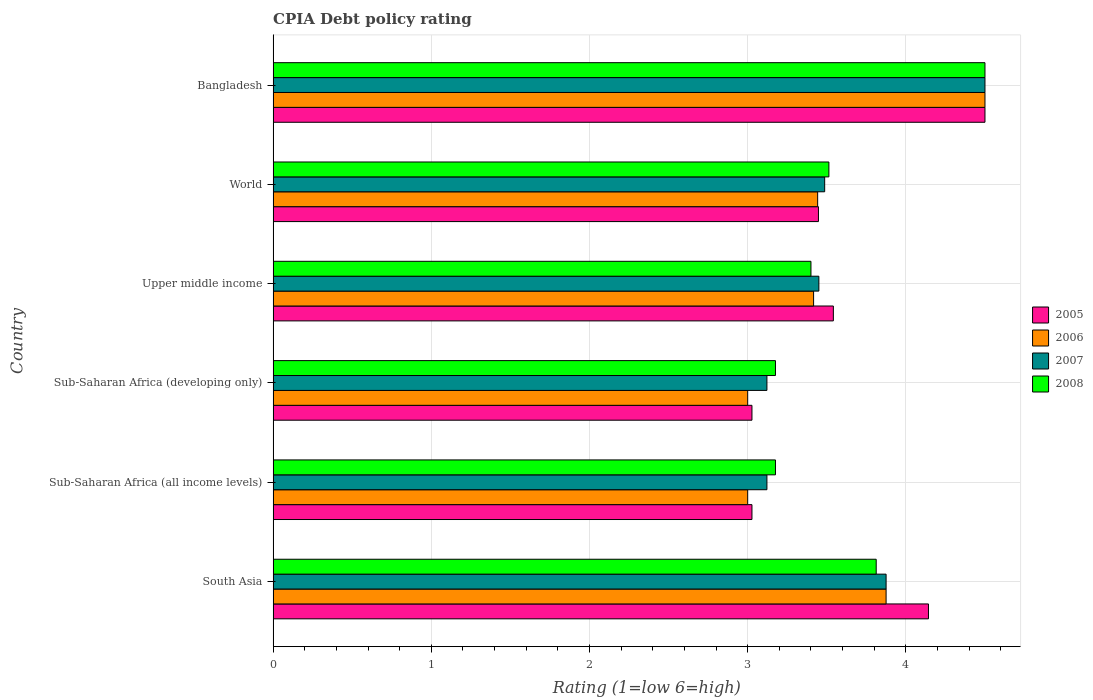How many different coloured bars are there?
Ensure brevity in your answer.  4. How many groups of bars are there?
Your answer should be very brief. 6. Are the number of bars on each tick of the Y-axis equal?
Provide a short and direct response. Yes. How many bars are there on the 6th tick from the top?
Offer a very short reply. 4. How many bars are there on the 5th tick from the bottom?
Offer a terse response. 4. What is the label of the 3rd group of bars from the top?
Make the answer very short. Upper middle income. In how many cases, is the number of bars for a given country not equal to the number of legend labels?
Provide a short and direct response. 0. What is the CPIA rating in 2007 in South Asia?
Give a very brief answer. 3.88. Across all countries, what is the minimum CPIA rating in 2006?
Provide a succinct answer. 3. In which country was the CPIA rating in 2007 minimum?
Your response must be concise. Sub-Saharan Africa (all income levels). What is the total CPIA rating in 2007 in the graph?
Provide a succinct answer. 21.55. What is the difference between the CPIA rating in 2007 in Bangladesh and that in Upper middle income?
Ensure brevity in your answer.  1.05. What is the difference between the CPIA rating in 2005 in South Asia and the CPIA rating in 2007 in Sub-Saharan Africa (developing only)?
Your answer should be very brief. 1.02. What is the average CPIA rating in 2008 per country?
Give a very brief answer. 3.6. What is the difference between the CPIA rating in 2005 and CPIA rating in 2008 in South Asia?
Provide a succinct answer. 0.33. In how many countries, is the CPIA rating in 2005 greater than 3.6 ?
Make the answer very short. 2. What is the ratio of the CPIA rating in 2008 in Sub-Saharan Africa (developing only) to that in World?
Make the answer very short. 0.9. What is the difference between the highest and the second highest CPIA rating in 2008?
Ensure brevity in your answer.  0.69. What is the difference between the highest and the lowest CPIA rating in 2006?
Offer a terse response. 1.5. Is it the case that in every country, the sum of the CPIA rating in 2007 and CPIA rating in 2005 is greater than the sum of CPIA rating in 2008 and CPIA rating in 2006?
Provide a short and direct response. No. What does the 1st bar from the top in South Asia represents?
Your answer should be very brief. 2008. Are all the bars in the graph horizontal?
Keep it short and to the point. Yes. What is the difference between two consecutive major ticks on the X-axis?
Your answer should be compact. 1. Are the values on the major ticks of X-axis written in scientific E-notation?
Keep it short and to the point. No. Does the graph contain any zero values?
Offer a terse response. No. How are the legend labels stacked?
Your response must be concise. Vertical. What is the title of the graph?
Provide a succinct answer. CPIA Debt policy rating. What is the label or title of the Y-axis?
Your response must be concise. Country. What is the Rating (1=low 6=high) in 2005 in South Asia?
Make the answer very short. 4.14. What is the Rating (1=low 6=high) of 2006 in South Asia?
Ensure brevity in your answer.  3.88. What is the Rating (1=low 6=high) in 2007 in South Asia?
Offer a very short reply. 3.88. What is the Rating (1=low 6=high) of 2008 in South Asia?
Ensure brevity in your answer.  3.81. What is the Rating (1=low 6=high) in 2005 in Sub-Saharan Africa (all income levels)?
Ensure brevity in your answer.  3.03. What is the Rating (1=low 6=high) in 2007 in Sub-Saharan Africa (all income levels)?
Provide a short and direct response. 3.12. What is the Rating (1=low 6=high) in 2008 in Sub-Saharan Africa (all income levels)?
Keep it short and to the point. 3.18. What is the Rating (1=low 6=high) in 2005 in Sub-Saharan Africa (developing only)?
Your answer should be very brief. 3.03. What is the Rating (1=low 6=high) of 2007 in Sub-Saharan Africa (developing only)?
Offer a terse response. 3.12. What is the Rating (1=low 6=high) of 2008 in Sub-Saharan Africa (developing only)?
Ensure brevity in your answer.  3.18. What is the Rating (1=low 6=high) in 2005 in Upper middle income?
Your answer should be compact. 3.54. What is the Rating (1=low 6=high) in 2006 in Upper middle income?
Give a very brief answer. 3.42. What is the Rating (1=low 6=high) in 2007 in Upper middle income?
Your answer should be compact. 3.45. What is the Rating (1=low 6=high) in 2008 in Upper middle income?
Your response must be concise. 3.4. What is the Rating (1=low 6=high) of 2005 in World?
Give a very brief answer. 3.45. What is the Rating (1=low 6=high) in 2006 in World?
Your answer should be very brief. 3.44. What is the Rating (1=low 6=high) in 2007 in World?
Offer a terse response. 3.49. What is the Rating (1=low 6=high) in 2008 in World?
Make the answer very short. 3.51. What is the Rating (1=low 6=high) of 2005 in Bangladesh?
Your answer should be very brief. 4.5. What is the Rating (1=low 6=high) in 2007 in Bangladesh?
Your response must be concise. 4.5. What is the Rating (1=low 6=high) of 2008 in Bangladesh?
Offer a terse response. 4.5. Across all countries, what is the maximum Rating (1=low 6=high) in 2006?
Provide a short and direct response. 4.5. Across all countries, what is the maximum Rating (1=low 6=high) in 2007?
Offer a terse response. 4.5. Across all countries, what is the maximum Rating (1=low 6=high) in 2008?
Offer a very short reply. 4.5. Across all countries, what is the minimum Rating (1=low 6=high) in 2005?
Provide a succinct answer. 3.03. Across all countries, what is the minimum Rating (1=low 6=high) of 2007?
Offer a very short reply. 3.12. Across all countries, what is the minimum Rating (1=low 6=high) of 2008?
Your response must be concise. 3.18. What is the total Rating (1=low 6=high) in 2005 in the graph?
Your answer should be compact. 21.69. What is the total Rating (1=low 6=high) in 2006 in the graph?
Ensure brevity in your answer.  21.23. What is the total Rating (1=low 6=high) in 2007 in the graph?
Make the answer very short. 21.55. What is the total Rating (1=low 6=high) of 2008 in the graph?
Give a very brief answer. 21.58. What is the difference between the Rating (1=low 6=high) of 2005 in South Asia and that in Sub-Saharan Africa (all income levels)?
Offer a very short reply. 1.12. What is the difference between the Rating (1=low 6=high) of 2007 in South Asia and that in Sub-Saharan Africa (all income levels)?
Make the answer very short. 0.75. What is the difference between the Rating (1=low 6=high) in 2008 in South Asia and that in Sub-Saharan Africa (all income levels)?
Provide a short and direct response. 0.64. What is the difference between the Rating (1=low 6=high) in 2005 in South Asia and that in Sub-Saharan Africa (developing only)?
Ensure brevity in your answer.  1.12. What is the difference between the Rating (1=low 6=high) in 2007 in South Asia and that in Sub-Saharan Africa (developing only)?
Your response must be concise. 0.75. What is the difference between the Rating (1=low 6=high) of 2008 in South Asia and that in Sub-Saharan Africa (developing only)?
Keep it short and to the point. 0.64. What is the difference between the Rating (1=low 6=high) in 2005 in South Asia and that in Upper middle income?
Your answer should be compact. 0.6. What is the difference between the Rating (1=low 6=high) in 2006 in South Asia and that in Upper middle income?
Provide a short and direct response. 0.46. What is the difference between the Rating (1=low 6=high) of 2007 in South Asia and that in Upper middle income?
Ensure brevity in your answer.  0.42. What is the difference between the Rating (1=low 6=high) of 2008 in South Asia and that in Upper middle income?
Give a very brief answer. 0.41. What is the difference between the Rating (1=low 6=high) of 2005 in South Asia and that in World?
Ensure brevity in your answer.  0.7. What is the difference between the Rating (1=low 6=high) of 2006 in South Asia and that in World?
Your answer should be compact. 0.43. What is the difference between the Rating (1=low 6=high) in 2007 in South Asia and that in World?
Give a very brief answer. 0.39. What is the difference between the Rating (1=low 6=high) of 2008 in South Asia and that in World?
Your answer should be compact. 0.3. What is the difference between the Rating (1=low 6=high) in 2005 in South Asia and that in Bangladesh?
Your answer should be very brief. -0.36. What is the difference between the Rating (1=low 6=high) in 2006 in South Asia and that in Bangladesh?
Your answer should be very brief. -0.62. What is the difference between the Rating (1=low 6=high) in 2007 in South Asia and that in Bangladesh?
Give a very brief answer. -0.62. What is the difference between the Rating (1=low 6=high) of 2008 in South Asia and that in Bangladesh?
Your answer should be very brief. -0.69. What is the difference between the Rating (1=low 6=high) in 2005 in Sub-Saharan Africa (all income levels) and that in Sub-Saharan Africa (developing only)?
Offer a very short reply. 0. What is the difference between the Rating (1=low 6=high) of 2008 in Sub-Saharan Africa (all income levels) and that in Sub-Saharan Africa (developing only)?
Provide a succinct answer. 0. What is the difference between the Rating (1=low 6=high) in 2005 in Sub-Saharan Africa (all income levels) and that in Upper middle income?
Give a very brief answer. -0.51. What is the difference between the Rating (1=low 6=high) of 2006 in Sub-Saharan Africa (all income levels) and that in Upper middle income?
Your response must be concise. -0.42. What is the difference between the Rating (1=low 6=high) in 2007 in Sub-Saharan Africa (all income levels) and that in Upper middle income?
Your response must be concise. -0.33. What is the difference between the Rating (1=low 6=high) in 2008 in Sub-Saharan Africa (all income levels) and that in Upper middle income?
Offer a terse response. -0.22. What is the difference between the Rating (1=low 6=high) in 2005 in Sub-Saharan Africa (all income levels) and that in World?
Your answer should be compact. -0.42. What is the difference between the Rating (1=low 6=high) of 2006 in Sub-Saharan Africa (all income levels) and that in World?
Keep it short and to the point. -0.44. What is the difference between the Rating (1=low 6=high) of 2007 in Sub-Saharan Africa (all income levels) and that in World?
Ensure brevity in your answer.  -0.36. What is the difference between the Rating (1=low 6=high) in 2008 in Sub-Saharan Africa (all income levels) and that in World?
Give a very brief answer. -0.34. What is the difference between the Rating (1=low 6=high) in 2005 in Sub-Saharan Africa (all income levels) and that in Bangladesh?
Your answer should be compact. -1.47. What is the difference between the Rating (1=low 6=high) of 2007 in Sub-Saharan Africa (all income levels) and that in Bangladesh?
Your response must be concise. -1.38. What is the difference between the Rating (1=low 6=high) of 2008 in Sub-Saharan Africa (all income levels) and that in Bangladesh?
Make the answer very short. -1.32. What is the difference between the Rating (1=low 6=high) of 2005 in Sub-Saharan Africa (developing only) and that in Upper middle income?
Ensure brevity in your answer.  -0.51. What is the difference between the Rating (1=low 6=high) in 2006 in Sub-Saharan Africa (developing only) and that in Upper middle income?
Keep it short and to the point. -0.42. What is the difference between the Rating (1=low 6=high) in 2007 in Sub-Saharan Africa (developing only) and that in Upper middle income?
Provide a succinct answer. -0.33. What is the difference between the Rating (1=low 6=high) in 2008 in Sub-Saharan Africa (developing only) and that in Upper middle income?
Ensure brevity in your answer.  -0.22. What is the difference between the Rating (1=low 6=high) in 2005 in Sub-Saharan Africa (developing only) and that in World?
Offer a terse response. -0.42. What is the difference between the Rating (1=low 6=high) of 2006 in Sub-Saharan Africa (developing only) and that in World?
Keep it short and to the point. -0.44. What is the difference between the Rating (1=low 6=high) of 2007 in Sub-Saharan Africa (developing only) and that in World?
Offer a terse response. -0.36. What is the difference between the Rating (1=low 6=high) in 2008 in Sub-Saharan Africa (developing only) and that in World?
Ensure brevity in your answer.  -0.34. What is the difference between the Rating (1=low 6=high) of 2005 in Sub-Saharan Africa (developing only) and that in Bangladesh?
Make the answer very short. -1.47. What is the difference between the Rating (1=low 6=high) in 2007 in Sub-Saharan Africa (developing only) and that in Bangladesh?
Give a very brief answer. -1.38. What is the difference between the Rating (1=low 6=high) in 2008 in Sub-Saharan Africa (developing only) and that in Bangladesh?
Provide a succinct answer. -1.32. What is the difference between the Rating (1=low 6=high) in 2005 in Upper middle income and that in World?
Make the answer very short. 0.09. What is the difference between the Rating (1=low 6=high) in 2006 in Upper middle income and that in World?
Give a very brief answer. -0.03. What is the difference between the Rating (1=low 6=high) in 2007 in Upper middle income and that in World?
Make the answer very short. -0.04. What is the difference between the Rating (1=low 6=high) of 2008 in Upper middle income and that in World?
Give a very brief answer. -0.11. What is the difference between the Rating (1=low 6=high) of 2005 in Upper middle income and that in Bangladesh?
Give a very brief answer. -0.96. What is the difference between the Rating (1=low 6=high) in 2006 in Upper middle income and that in Bangladesh?
Provide a short and direct response. -1.08. What is the difference between the Rating (1=low 6=high) in 2007 in Upper middle income and that in Bangladesh?
Keep it short and to the point. -1.05. What is the difference between the Rating (1=low 6=high) of 2005 in World and that in Bangladesh?
Offer a terse response. -1.05. What is the difference between the Rating (1=low 6=high) of 2006 in World and that in Bangladesh?
Make the answer very short. -1.06. What is the difference between the Rating (1=low 6=high) of 2007 in World and that in Bangladesh?
Make the answer very short. -1.01. What is the difference between the Rating (1=low 6=high) of 2008 in World and that in Bangladesh?
Your response must be concise. -0.99. What is the difference between the Rating (1=low 6=high) in 2005 in South Asia and the Rating (1=low 6=high) in 2006 in Sub-Saharan Africa (all income levels)?
Make the answer very short. 1.14. What is the difference between the Rating (1=low 6=high) in 2005 in South Asia and the Rating (1=low 6=high) in 2007 in Sub-Saharan Africa (all income levels)?
Provide a succinct answer. 1.02. What is the difference between the Rating (1=low 6=high) of 2005 in South Asia and the Rating (1=low 6=high) of 2008 in Sub-Saharan Africa (all income levels)?
Offer a very short reply. 0.97. What is the difference between the Rating (1=low 6=high) of 2006 in South Asia and the Rating (1=low 6=high) of 2007 in Sub-Saharan Africa (all income levels)?
Provide a short and direct response. 0.75. What is the difference between the Rating (1=low 6=high) in 2006 in South Asia and the Rating (1=low 6=high) in 2008 in Sub-Saharan Africa (all income levels)?
Provide a succinct answer. 0.7. What is the difference between the Rating (1=low 6=high) of 2007 in South Asia and the Rating (1=low 6=high) of 2008 in Sub-Saharan Africa (all income levels)?
Make the answer very short. 0.7. What is the difference between the Rating (1=low 6=high) in 2005 in South Asia and the Rating (1=low 6=high) in 2007 in Sub-Saharan Africa (developing only)?
Ensure brevity in your answer.  1.02. What is the difference between the Rating (1=low 6=high) in 2005 in South Asia and the Rating (1=low 6=high) in 2008 in Sub-Saharan Africa (developing only)?
Make the answer very short. 0.97. What is the difference between the Rating (1=low 6=high) in 2006 in South Asia and the Rating (1=low 6=high) in 2007 in Sub-Saharan Africa (developing only)?
Provide a succinct answer. 0.75. What is the difference between the Rating (1=low 6=high) in 2006 in South Asia and the Rating (1=low 6=high) in 2008 in Sub-Saharan Africa (developing only)?
Provide a short and direct response. 0.7. What is the difference between the Rating (1=low 6=high) in 2007 in South Asia and the Rating (1=low 6=high) in 2008 in Sub-Saharan Africa (developing only)?
Keep it short and to the point. 0.7. What is the difference between the Rating (1=low 6=high) in 2005 in South Asia and the Rating (1=low 6=high) in 2006 in Upper middle income?
Your answer should be very brief. 0.73. What is the difference between the Rating (1=low 6=high) in 2005 in South Asia and the Rating (1=low 6=high) in 2007 in Upper middle income?
Offer a very short reply. 0.69. What is the difference between the Rating (1=low 6=high) in 2005 in South Asia and the Rating (1=low 6=high) in 2008 in Upper middle income?
Make the answer very short. 0.74. What is the difference between the Rating (1=low 6=high) of 2006 in South Asia and the Rating (1=low 6=high) of 2007 in Upper middle income?
Your answer should be compact. 0.42. What is the difference between the Rating (1=low 6=high) in 2006 in South Asia and the Rating (1=low 6=high) in 2008 in Upper middle income?
Keep it short and to the point. 0.47. What is the difference between the Rating (1=low 6=high) of 2007 in South Asia and the Rating (1=low 6=high) of 2008 in Upper middle income?
Give a very brief answer. 0.47. What is the difference between the Rating (1=low 6=high) in 2005 in South Asia and the Rating (1=low 6=high) in 2006 in World?
Keep it short and to the point. 0.7. What is the difference between the Rating (1=low 6=high) in 2005 in South Asia and the Rating (1=low 6=high) in 2007 in World?
Make the answer very short. 0.66. What is the difference between the Rating (1=low 6=high) of 2005 in South Asia and the Rating (1=low 6=high) of 2008 in World?
Make the answer very short. 0.63. What is the difference between the Rating (1=low 6=high) in 2006 in South Asia and the Rating (1=low 6=high) in 2007 in World?
Your response must be concise. 0.39. What is the difference between the Rating (1=low 6=high) of 2006 in South Asia and the Rating (1=low 6=high) of 2008 in World?
Offer a terse response. 0.36. What is the difference between the Rating (1=low 6=high) in 2007 in South Asia and the Rating (1=low 6=high) in 2008 in World?
Your answer should be very brief. 0.36. What is the difference between the Rating (1=low 6=high) in 2005 in South Asia and the Rating (1=low 6=high) in 2006 in Bangladesh?
Your answer should be very brief. -0.36. What is the difference between the Rating (1=low 6=high) of 2005 in South Asia and the Rating (1=low 6=high) of 2007 in Bangladesh?
Offer a terse response. -0.36. What is the difference between the Rating (1=low 6=high) of 2005 in South Asia and the Rating (1=low 6=high) of 2008 in Bangladesh?
Ensure brevity in your answer.  -0.36. What is the difference between the Rating (1=low 6=high) of 2006 in South Asia and the Rating (1=low 6=high) of 2007 in Bangladesh?
Offer a terse response. -0.62. What is the difference between the Rating (1=low 6=high) of 2006 in South Asia and the Rating (1=low 6=high) of 2008 in Bangladesh?
Your answer should be compact. -0.62. What is the difference between the Rating (1=low 6=high) of 2007 in South Asia and the Rating (1=low 6=high) of 2008 in Bangladesh?
Your response must be concise. -0.62. What is the difference between the Rating (1=low 6=high) of 2005 in Sub-Saharan Africa (all income levels) and the Rating (1=low 6=high) of 2006 in Sub-Saharan Africa (developing only)?
Your answer should be compact. 0.03. What is the difference between the Rating (1=low 6=high) of 2005 in Sub-Saharan Africa (all income levels) and the Rating (1=low 6=high) of 2007 in Sub-Saharan Africa (developing only)?
Your answer should be very brief. -0.09. What is the difference between the Rating (1=low 6=high) in 2005 in Sub-Saharan Africa (all income levels) and the Rating (1=low 6=high) in 2008 in Sub-Saharan Africa (developing only)?
Give a very brief answer. -0.15. What is the difference between the Rating (1=low 6=high) of 2006 in Sub-Saharan Africa (all income levels) and the Rating (1=low 6=high) of 2007 in Sub-Saharan Africa (developing only)?
Ensure brevity in your answer.  -0.12. What is the difference between the Rating (1=low 6=high) of 2006 in Sub-Saharan Africa (all income levels) and the Rating (1=low 6=high) of 2008 in Sub-Saharan Africa (developing only)?
Your response must be concise. -0.18. What is the difference between the Rating (1=low 6=high) in 2007 in Sub-Saharan Africa (all income levels) and the Rating (1=low 6=high) in 2008 in Sub-Saharan Africa (developing only)?
Your answer should be very brief. -0.05. What is the difference between the Rating (1=low 6=high) in 2005 in Sub-Saharan Africa (all income levels) and the Rating (1=low 6=high) in 2006 in Upper middle income?
Ensure brevity in your answer.  -0.39. What is the difference between the Rating (1=low 6=high) in 2005 in Sub-Saharan Africa (all income levels) and the Rating (1=low 6=high) in 2007 in Upper middle income?
Provide a succinct answer. -0.42. What is the difference between the Rating (1=low 6=high) of 2005 in Sub-Saharan Africa (all income levels) and the Rating (1=low 6=high) of 2008 in Upper middle income?
Offer a terse response. -0.37. What is the difference between the Rating (1=low 6=high) of 2006 in Sub-Saharan Africa (all income levels) and the Rating (1=low 6=high) of 2007 in Upper middle income?
Offer a terse response. -0.45. What is the difference between the Rating (1=low 6=high) in 2007 in Sub-Saharan Africa (all income levels) and the Rating (1=low 6=high) in 2008 in Upper middle income?
Make the answer very short. -0.28. What is the difference between the Rating (1=low 6=high) in 2005 in Sub-Saharan Africa (all income levels) and the Rating (1=low 6=high) in 2006 in World?
Offer a very short reply. -0.42. What is the difference between the Rating (1=low 6=high) in 2005 in Sub-Saharan Africa (all income levels) and the Rating (1=low 6=high) in 2007 in World?
Your answer should be very brief. -0.46. What is the difference between the Rating (1=low 6=high) of 2005 in Sub-Saharan Africa (all income levels) and the Rating (1=low 6=high) of 2008 in World?
Provide a short and direct response. -0.49. What is the difference between the Rating (1=low 6=high) in 2006 in Sub-Saharan Africa (all income levels) and the Rating (1=low 6=high) in 2007 in World?
Your answer should be very brief. -0.49. What is the difference between the Rating (1=low 6=high) of 2006 in Sub-Saharan Africa (all income levels) and the Rating (1=low 6=high) of 2008 in World?
Make the answer very short. -0.51. What is the difference between the Rating (1=low 6=high) of 2007 in Sub-Saharan Africa (all income levels) and the Rating (1=low 6=high) of 2008 in World?
Ensure brevity in your answer.  -0.39. What is the difference between the Rating (1=low 6=high) in 2005 in Sub-Saharan Africa (all income levels) and the Rating (1=low 6=high) in 2006 in Bangladesh?
Provide a short and direct response. -1.47. What is the difference between the Rating (1=low 6=high) in 2005 in Sub-Saharan Africa (all income levels) and the Rating (1=low 6=high) in 2007 in Bangladesh?
Provide a short and direct response. -1.47. What is the difference between the Rating (1=low 6=high) of 2005 in Sub-Saharan Africa (all income levels) and the Rating (1=low 6=high) of 2008 in Bangladesh?
Make the answer very short. -1.47. What is the difference between the Rating (1=low 6=high) of 2006 in Sub-Saharan Africa (all income levels) and the Rating (1=low 6=high) of 2008 in Bangladesh?
Provide a short and direct response. -1.5. What is the difference between the Rating (1=low 6=high) of 2007 in Sub-Saharan Africa (all income levels) and the Rating (1=low 6=high) of 2008 in Bangladesh?
Provide a succinct answer. -1.38. What is the difference between the Rating (1=low 6=high) in 2005 in Sub-Saharan Africa (developing only) and the Rating (1=low 6=high) in 2006 in Upper middle income?
Make the answer very short. -0.39. What is the difference between the Rating (1=low 6=high) in 2005 in Sub-Saharan Africa (developing only) and the Rating (1=low 6=high) in 2007 in Upper middle income?
Ensure brevity in your answer.  -0.42. What is the difference between the Rating (1=low 6=high) of 2005 in Sub-Saharan Africa (developing only) and the Rating (1=low 6=high) of 2008 in Upper middle income?
Provide a short and direct response. -0.37. What is the difference between the Rating (1=low 6=high) in 2006 in Sub-Saharan Africa (developing only) and the Rating (1=low 6=high) in 2007 in Upper middle income?
Ensure brevity in your answer.  -0.45. What is the difference between the Rating (1=low 6=high) of 2006 in Sub-Saharan Africa (developing only) and the Rating (1=low 6=high) of 2008 in Upper middle income?
Your response must be concise. -0.4. What is the difference between the Rating (1=low 6=high) of 2007 in Sub-Saharan Africa (developing only) and the Rating (1=low 6=high) of 2008 in Upper middle income?
Make the answer very short. -0.28. What is the difference between the Rating (1=low 6=high) of 2005 in Sub-Saharan Africa (developing only) and the Rating (1=low 6=high) of 2006 in World?
Keep it short and to the point. -0.42. What is the difference between the Rating (1=low 6=high) of 2005 in Sub-Saharan Africa (developing only) and the Rating (1=low 6=high) of 2007 in World?
Ensure brevity in your answer.  -0.46. What is the difference between the Rating (1=low 6=high) of 2005 in Sub-Saharan Africa (developing only) and the Rating (1=low 6=high) of 2008 in World?
Your answer should be very brief. -0.49. What is the difference between the Rating (1=low 6=high) in 2006 in Sub-Saharan Africa (developing only) and the Rating (1=low 6=high) in 2007 in World?
Provide a succinct answer. -0.49. What is the difference between the Rating (1=low 6=high) of 2006 in Sub-Saharan Africa (developing only) and the Rating (1=low 6=high) of 2008 in World?
Keep it short and to the point. -0.51. What is the difference between the Rating (1=low 6=high) in 2007 in Sub-Saharan Africa (developing only) and the Rating (1=low 6=high) in 2008 in World?
Your response must be concise. -0.39. What is the difference between the Rating (1=low 6=high) of 2005 in Sub-Saharan Africa (developing only) and the Rating (1=low 6=high) of 2006 in Bangladesh?
Your answer should be compact. -1.47. What is the difference between the Rating (1=low 6=high) in 2005 in Sub-Saharan Africa (developing only) and the Rating (1=low 6=high) in 2007 in Bangladesh?
Give a very brief answer. -1.47. What is the difference between the Rating (1=low 6=high) of 2005 in Sub-Saharan Africa (developing only) and the Rating (1=low 6=high) of 2008 in Bangladesh?
Your answer should be very brief. -1.47. What is the difference between the Rating (1=low 6=high) in 2006 in Sub-Saharan Africa (developing only) and the Rating (1=low 6=high) in 2007 in Bangladesh?
Your answer should be very brief. -1.5. What is the difference between the Rating (1=low 6=high) of 2006 in Sub-Saharan Africa (developing only) and the Rating (1=low 6=high) of 2008 in Bangladesh?
Keep it short and to the point. -1.5. What is the difference between the Rating (1=low 6=high) in 2007 in Sub-Saharan Africa (developing only) and the Rating (1=low 6=high) in 2008 in Bangladesh?
Provide a succinct answer. -1.38. What is the difference between the Rating (1=low 6=high) in 2005 in Upper middle income and the Rating (1=low 6=high) in 2006 in World?
Your answer should be very brief. 0.1. What is the difference between the Rating (1=low 6=high) of 2005 in Upper middle income and the Rating (1=low 6=high) of 2007 in World?
Your answer should be very brief. 0.06. What is the difference between the Rating (1=low 6=high) of 2005 in Upper middle income and the Rating (1=low 6=high) of 2008 in World?
Your response must be concise. 0.03. What is the difference between the Rating (1=low 6=high) in 2006 in Upper middle income and the Rating (1=low 6=high) in 2007 in World?
Your answer should be very brief. -0.07. What is the difference between the Rating (1=low 6=high) in 2006 in Upper middle income and the Rating (1=low 6=high) in 2008 in World?
Make the answer very short. -0.1. What is the difference between the Rating (1=low 6=high) in 2007 in Upper middle income and the Rating (1=low 6=high) in 2008 in World?
Your answer should be compact. -0.06. What is the difference between the Rating (1=low 6=high) of 2005 in Upper middle income and the Rating (1=low 6=high) of 2006 in Bangladesh?
Ensure brevity in your answer.  -0.96. What is the difference between the Rating (1=low 6=high) of 2005 in Upper middle income and the Rating (1=low 6=high) of 2007 in Bangladesh?
Provide a short and direct response. -0.96. What is the difference between the Rating (1=low 6=high) in 2005 in Upper middle income and the Rating (1=low 6=high) in 2008 in Bangladesh?
Your answer should be compact. -0.96. What is the difference between the Rating (1=low 6=high) of 2006 in Upper middle income and the Rating (1=low 6=high) of 2007 in Bangladesh?
Offer a terse response. -1.08. What is the difference between the Rating (1=low 6=high) of 2006 in Upper middle income and the Rating (1=low 6=high) of 2008 in Bangladesh?
Provide a succinct answer. -1.08. What is the difference between the Rating (1=low 6=high) of 2007 in Upper middle income and the Rating (1=low 6=high) of 2008 in Bangladesh?
Offer a terse response. -1.05. What is the difference between the Rating (1=low 6=high) of 2005 in World and the Rating (1=low 6=high) of 2006 in Bangladesh?
Your response must be concise. -1.05. What is the difference between the Rating (1=low 6=high) of 2005 in World and the Rating (1=low 6=high) of 2007 in Bangladesh?
Offer a terse response. -1.05. What is the difference between the Rating (1=low 6=high) of 2005 in World and the Rating (1=low 6=high) of 2008 in Bangladesh?
Keep it short and to the point. -1.05. What is the difference between the Rating (1=low 6=high) in 2006 in World and the Rating (1=low 6=high) in 2007 in Bangladesh?
Provide a succinct answer. -1.06. What is the difference between the Rating (1=low 6=high) of 2006 in World and the Rating (1=low 6=high) of 2008 in Bangladesh?
Keep it short and to the point. -1.06. What is the difference between the Rating (1=low 6=high) of 2007 in World and the Rating (1=low 6=high) of 2008 in Bangladesh?
Offer a very short reply. -1.01. What is the average Rating (1=low 6=high) of 2005 per country?
Provide a succinct answer. 3.61. What is the average Rating (1=low 6=high) in 2006 per country?
Ensure brevity in your answer.  3.54. What is the average Rating (1=low 6=high) of 2007 per country?
Provide a short and direct response. 3.59. What is the average Rating (1=low 6=high) of 2008 per country?
Your answer should be compact. 3.6. What is the difference between the Rating (1=low 6=high) in 2005 and Rating (1=low 6=high) in 2006 in South Asia?
Your answer should be very brief. 0.27. What is the difference between the Rating (1=low 6=high) of 2005 and Rating (1=low 6=high) of 2007 in South Asia?
Give a very brief answer. 0.27. What is the difference between the Rating (1=low 6=high) in 2005 and Rating (1=low 6=high) in 2008 in South Asia?
Provide a succinct answer. 0.33. What is the difference between the Rating (1=low 6=high) in 2006 and Rating (1=low 6=high) in 2007 in South Asia?
Offer a terse response. 0. What is the difference between the Rating (1=low 6=high) in 2006 and Rating (1=low 6=high) in 2008 in South Asia?
Your answer should be compact. 0.06. What is the difference between the Rating (1=low 6=high) in 2007 and Rating (1=low 6=high) in 2008 in South Asia?
Make the answer very short. 0.06. What is the difference between the Rating (1=low 6=high) in 2005 and Rating (1=low 6=high) in 2006 in Sub-Saharan Africa (all income levels)?
Keep it short and to the point. 0.03. What is the difference between the Rating (1=low 6=high) of 2005 and Rating (1=low 6=high) of 2007 in Sub-Saharan Africa (all income levels)?
Your response must be concise. -0.09. What is the difference between the Rating (1=low 6=high) of 2005 and Rating (1=low 6=high) of 2008 in Sub-Saharan Africa (all income levels)?
Offer a very short reply. -0.15. What is the difference between the Rating (1=low 6=high) in 2006 and Rating (1=low 6=high) in 2007 in Sub-Saharan Africa (all income levels)?
Keep it short and to the point. -0.12. What is the difference between the Rating (1=low 6=high) in 2006 and Rating (1=low 6=high) in 2008 in Sub-Saharan Africa (all income levels)?
Your answer should be very brief. -0.18. What is the difference between the Rating (1=low 6=high) in 2007 and Rating (1=low 6=high) in 2008 in Sub-Saharan Africa (all income levels)?
Provide a short and direct response. -0.05. What is the difference between the Rating (1=low 6=high) of 2005 and Rating (1=low 6=high) of 2006 in Sub-Saharan Africa (developing only)?
Ensure brevity in your answer.  0.03. What is the difference between the Rating (1=low 6=high) in 2005 and Rating (1=low 6=high) in 2007 in Sub-Saharan Africa (developing only)?
Offer a terse response. -0.09. What is the difference between the Rating (1=low 6=high) of 2005 and Rating (1=low 6=high) of 2008 in Sub-Saharan Africa (developing only)?
Keep it short and to the point. -0.15. What is the difference between the Rating (1=low 6=high) in 2006 and Rating (1=low 6=high) in 2007 in Sub-Saharan Africa (developing only)?
Give a very brief answer. -0.12. What is the difference between the Rating (1=low 6=high) in 2006 and Rating (1=low 6=high) in 2008 in Sub-Saharan Africa (developing only)?
Your answer should be very brief. -0.18. What is the difference between the Rating (1=low 6=high) in 2007 and Rating (1=low 6=high) in 2008 in Sub-Saharan Africa (developing only)?
Offer a terse response. -0.05. What is the difference between the Rating (1=low 6=high) of 2005 and Rating (1=low 6=high) of 2007 in Upper middle income?
Provide a short and direct response. 0.09. What is the difference between the Rating (1=low 6=high) in 2005 and Rating (1=low 6=high) in 2008 in Upper middle income?
Provide a short and direct response. 0.14. What is the difference between the Rating (1=low 6=high) of 2006 and Rating (1=low 6=high) of 2007 in Upper middle income?
Keep it short and to the point. -0.03. What is the difference between the Rating (1=low 6=high) of 2006 and Rating (1=low 6=high) of 2008 in Upper middle income?
Offer a very short reply. 0.02. What is the difference between the Rating (1=low 6=high) of 2007 and Rating (1=low 6=high) of 2008 in Upper middle income?
Make the answer very short. 0.05. What is the difference between the Rating (1=low 6=high) of 2005 and Rating (1=low 6=high) of 2006 in World?
Provide a short and direct response. 0.01. What is the difference between the Rating (1=low 6=high) of 2005 and Rating (1=low 6=high) of 2007 in World?
Ensure brevity in your answer.  -0.04. What is the difference between the Rating (1=low 6=high) of 2005 and Rating (1=low 6=high) of 2008 in World?
Provide a short and direct response. -0.07. What is the difference between the Rating (1=low 6=high) in 2006 and Rating (1=low 6=high) in 2007 in World?
Your answer should be compact. -0.04. What is the difference between the Rating (1=low 6=high) in 2006 and Rating (1=low 6=high) in 2008 in World?
Your answer should be compact. -0.07. What is the difference between the Rating (1=low 6=high) in 2007 and Rating (1=low 6=high) in 2008 in World?
Your answer should be compact. -0.03. What is the difference between the Rating (1=low 6=high) in 2005 and Rating (1=low 6=high) in 2006 in Bangladesh?
Provide a succinct answer. 0. What is the difference between the Rating (1=low 6=high) in 2005 and Rating (1=low 6=high) in 2008 in Bangladesh?
Your response must be concise. 0. What is the difference between the Rating (1=low 6=high) in 2006 and Rating (1=low 6=high) in 2008 in Bangladesh?
Provide a succinct answer. 0. What is the difference between the Rating (1=low 6=high) of 2007 and Rating (1=low 6=high) of 2008 in Bangladesh?
Ensure brevity in your answer.  0. What is the ratio of the Rating (1=low 6=high) of 2005 in South Asia to that in Sub-Saharan Africa (all income levels)?
Ensure brevity in your answer.  1.37. What is the ratio of the Rating (1=low 6=high) in 2006 in South Asia to that in Sub-Saharan Africa (all income levels)?
Give a very brief answer. 1.29. What is the ratio of the Rating (1=low 6=high) in 2007 in South Asia to that in Sub-Saharan Africa (all income levels)?
Provide a succinct answer. 1.24. What is the ratio of the Rating (1=low 6=high) of 2008 in South Asia to that in Sub-Saharan Africa (all income levels)?
Offer a terse response. 1.2. What is the ratio of the Rating (1=low 6=high) in 2005 in South Asia to that in Sub-Saharan Africa (developing only)?
Offer a terse response. 1.37. What is the ratio of the Rating (1=low 6=high) of 2006 in South Asia to that in Sub-Saharan Africa (developing only)?
Ensure brevity in your answer.  1.29. What is the ratio of the Rating (1=low 6=high) in 2007 in South Asia to that in Sub-Saharan Africa (developing only)?
Your answer should be very brief. 1.24. What is the ratio of the Rating (1=low 6=high) in 2008 in South Asia to that in Sub-Saharan Africa (developing only)?
Your answer should be very brief. 1.2. What is the ratio of the Rating (1=low 6=high) of 2005 in South Asia to that in Upper middle income?
Give a very brief answer. 1.17. What is the ratio of the Rating (1=low 6=high) in 2006 in South Asia to that in Upper middle income?
Your response must be concise. 1.13. What is the ratio of the Rating (1=low 6=high) of 2007 in South Asia to that in Upper middle income?
Your response must be concise. 1.12. What is the ratio of the Rating (1=low 6=high) of 2008 in South Asia to that in Upper middle income?
Your response must be concise. 1.12. What is the ratio of the Rating (1=low 6=high) of 2005 in South Asia to that in World?
Provide a short and direct response. 1.2. What is the ratio of the Rating (1=low 6=high) of 2006 in South Asia to that in World?
Offer a very short reply. 1.13. What is the ratio of the Rating (1=low 6=high) of 2007 in South Asia to that in World?
Offer a very short reply. 1.11. What is the ratio of the Rating (1=low 6=high) of 2008 in South Asia to that in World?
Your answer should be compact. 1.09. What is the ratio of the Rating (1=low 6=high) of 2005 in South Asia to that in Bangladesh?
Provide a short and direct response. 0.92. What is the ratio of the Rating (1=low 6=high) in 2006 in South Asia to that in Bangladesh?
Provide a short and direct response. 0.86. What is the ratio of the Rating (1=low 6=high) in 2007 in South Asia to that in Bangladesh?
Offer a terse response. 0.86. What is the ratio of the Rating (1=low 6=high) of 2008 in South Asia to that in Bangladesh?
Provide a succinct answer. 0.85. What is the ratio of the Rating (1=low 6=high) in 2006 in Sub-Saharan Africa (all income levels) to that in Sub-Saharan Africa (developing only)?
Keep it short and to the point. 1. What is the ratio of the Rating (1=low 6=high) in 2007 in Sub-Saharan Africa (all income levels) to that in Sub-Saharan Africa (developing only)?
Your answer should be very brief. 1. What is the ratio of the Rating (1=low 6=high) in 2005 in Sub-Saharan Africa (all income levels) to that in Upper middle income?
Ensure brevity in your answer.  0.85. What is the ratio of the Rating (1=low 6=high) in 2006 in Sub-Saharan Africa (all income levels) to that in Upper middle income?
Keep it short and to the point. 0.88. What is the ratio of the Rating (1=low 6=high) in 2007 in Sub-Saharan Africa (all income levels) to that in Upper middle income?
Offer a terse response. 0.9. What is the ratio of the Rating (1=low 6=high) of 2008 in Sub-Saharan Africa (all income levels) to that in Upper middle income?
Your answer should be very brief. 0.93. What is the ratio of the Rating (1=low 6=high) of 2005 in Sub-Saharan Africa (all income levels) to that in World?
Give a very brief answer. 0.88. What is the ratio of the Rating (1=low 6=high) in 2006 in Sub-Saharan Africa (all income levels) to that in World?
Offer a terse response. 0.87. What is the ratio of the Rating (1=low 6=high) of 2007 in Sub-Saharan Africa (all income levels) to that in World?
Keep it short and to the point. 0.9. What is the ratio of the Rating (1=low 6=high) of 2008 in Sub-Saharan Africa (all income levels) to that in World?
Your answer should be very brief. 0.9. What is the ratio of the Rating (1=low 6=high) of 2005 in Sub-Saharan Africa (all income levels) to that in Bangladesh?
Your response must be concise. 0.67. What is the ratio of the Rating (1=low 6=high) in 2006 in Sub-Saharan Africa (all income levels) to that in Bangladesh?
Your answer should be very brief. 0.67. What is the ratio of the Rating (1=low 6=high) in 2007 in Sub-Saharan Africa (all income levels) to that in Bangladesh?
Provide a succinct answer. 0.69. What is the ratio of the Rating (1=low 6=high) of 2008 in Sub-Saharan Africa (all income levels) to that in Bangladesh?
Give a very brief answer. 0.71. What is the ratio of the Rating (1=low 6=high) in 2005 in Sub-Saharan Africa (developing only) to that in Upper middle income?
Offer a terse response. 0.85. What is the ratio of the Rating (1=low 6=high) of 2006 in Sub-Saharan Africa (developing only) to that in Upper middle income?
Provide a succinct answer. 0.88. What is the ratio of the Rating (1=low 6=high) in 2007 in Sub-Saharan Africa (developing only) to that in Upper middle income?
Make the answer very short. 0.9. What is the ratio of the Rating (1=low 6=high) in 2008 in Sub-Saharan Africa (developing only) to that in Upper middle income?
Provide a short and direct response. 0.93. What is the ratio of the Rating (1=low 6=high) in 2005 in Sub-Saharan Africa (developing only) to that in World?
Your answer should be compact. 0.88. What is the ratio of the Rating (1=low 6=high) of 2006 in Sub-Saharan Africa (developing only) to that in World?
Make the answer very short. 0.87. What is the ratio of the Rating (1=low 6=high) in 2007 in Sub-Saharan Africa (developing only) to that in World?
Keep it short and to the point. 0.9. What is the ratio of the Rating (1=low 6=high) of 2008 in Sub-Saharan Africa (developing only) to that in World?
Offer a terse response. 0.9. What is the ratio of the Rating (1=low 6=high) of 2005 in Sub-Saharan Africa (developing only) to that in Bangladesh?
Provide a short and direct response. 0.67. What is the ratio of the Rating (1=low 6=high) in 2006 in Sub-Saharan Africa (developing only) to that in Bangladesh?
Provide a short and direct response. 0.67. What is the ratio of the Rating (1=low 6=high) in 2007 in Sub-Saharan Africa (developing only) to that in Bangladesh?
Make the answer very short. 0.69. What is the ratio of the Rating (1=low 6=high) in 2008 in Sub-Saharan Africa (developing only) to that in Bangladesh?
Your answer should be very brief. 0.71. What is the ratio of the Rating (1=low 6=high) of 2005 in Upper middle income to that in World?
Provide a short and direct response. 1.03. What is the ratio of the Rating (1=low 6=high) of 2006 in Upper middle income to that in World?
Keep it short and to the point. 0.99. What is the ratio of the Rating (1=low 6=high) of 2005 in Upper middle income to that in Bangladesh?
Keep it short and to the point. 0.79. What is the ratio of the Rating (1=low 6=high) in 2006 in Upper middle income to that in Bangladesh?
Provide a short and direct response. 0.76. What is the ratio of the Rating (1=low 6=high) of 2007 in Upper middle income to that in Bangladesh?
Ensure brevity in your answer.  0.77. What is the ratio of the Rating (1=low 6=high) in 2008 in Upper middle income to that in Bangladesh?
Offer a terse response. 0.76. What is the ratio of the Rating (1=low 6=high) in 2005 in World to that in Bangladesh?
Keep it short and to the point. 0.77. What is the ratio of the Rating (1=low 6=high) in 2006 in World to that in Bangladesh?
Provide a succinct answer. 0.77. What is the ratio of the Rating (1=low 6=high) of 2007 in World to that in Bangladesh?
Your response must be concise. 0.77. What is the ratio of the Rating (1=low 6=high) in 2008 in World to that in Bangladesh?
Offer a very short reply. 0.78. What is the difference between the highest and the second highest Rating (1=low 6=high) in 2005?
Ensure brevity in your answer.  0.36. What is the difference between the highest and the second highest Rating (1=low 6=high) in 2006?
Your answer should be compact. 0.62. What is the difference between the highest and the second highest Rating (1=low 6=high) of 2007?
Offer a very short reply. 0.62. What is the difference between the highest and the second highest Rating (1=low 6=high) in 2008?
Provide a short and direct response. 0.69. What is the difference between the highest and the lowest Rating (1=low 6=high) of 2005?
Provide a short and direct response. 1.47. What is the difference between the highest and the lowest Rating (1=low 6=high) of 2006?
Ensure brevity in your answer.  1.5. What is the difference between the highest and the lowest Rating (1=low 6=high) in 2007?
Offer a very short reply. 1.38. What is the difference between the highest and the lowest Rating (1=low 6=high) of 2008?
Your response must be concise. 1.32. 